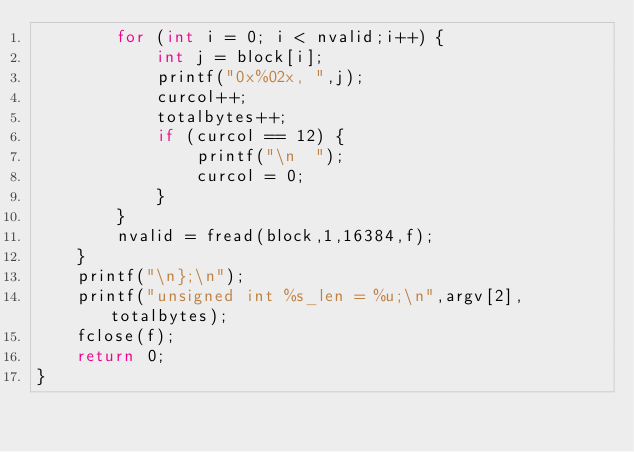Convert code to text. <code><loc_0><loc_0><loc_500><loc_500><_C++_>        for (int i = 0; i < nvalid;i++) {
            int j = block[i];
            printf("0x%02x, ",j);
            curcol++;
            totalbytes++;
            if (curcol == 12) {
                printf("\n  ");
                curcol = 0;
            }
        }
        nvalid = fread(block,1,16384,f);
    }
    printf("\n};\n");
    printf("unsigned int %s_len = %u;\n",argv[2],totalbytes);
    fclose(f);
    return 0;
}
</code> 